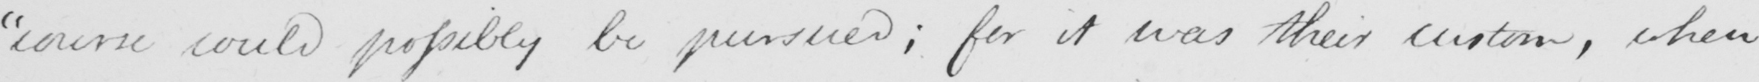What does this handwritten line say? " course could possibly be pursued ; for it was their custom , when 